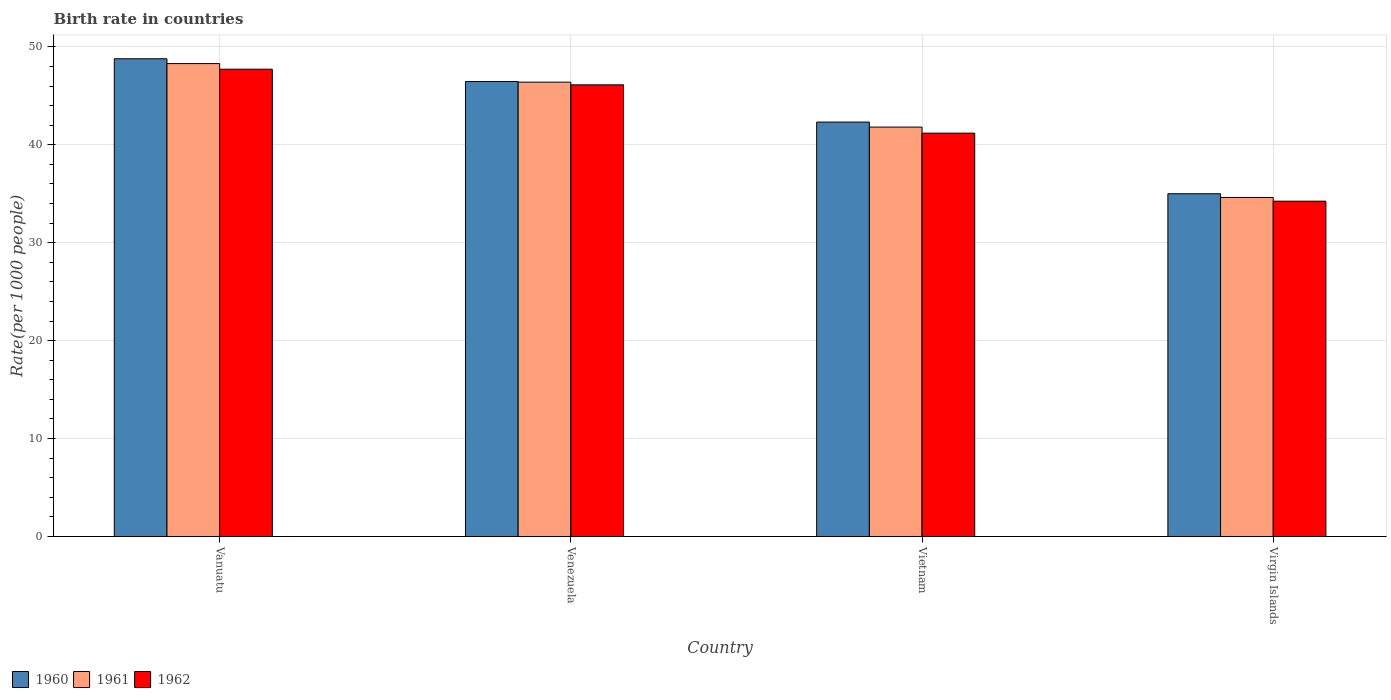How many different coloured bars are there?
Provide a short and direct response. 3. How many groups of bars are there?
Your answer should be compact. 4. How many bars are there on the 3rd tick from the right?
Offer a terse response. 3. What is the label of the 2nd group of bars from the left?
Provide a succinct answer. Venezuela. In how many cases, is the number of bars for a given country not equal to the number of legend labels?
Ensure brevity in your answer.  0. What is the birth rate in 1960 in Venezuela?
Ensure brevity in your answer.  46.46. Across all countries, what is the maximum birth rate in 1961?
Offer a terse response. 48.29. Across all countries, what is the minimum birth rate in 1961?
Provide a succinct answer. 34.62. In which country was the birth rate in 1960 maximum?
Make the answer very short. Vanuatu. In which country was the birth rate in 1962 minimum?
Provide a succinct answer. Virgin Islands. What is the total birth rate in 1960 in the graph?
Make the answer very short. 172.56. What is the difference between the birth rate in 1960 in Venezuela and that in Vietnam?
Your answer should be compact. 4.14. What is the difference between the birth rate in 1960 in Virgin Islands and the birth rate in 1961 in Vanuatu?
Provide a short and direct response. -13.29. What is the average birth rate in 1962 per country?
Keep it short and to the point. 42.32. What is the difference between the birth rate of/in 1961 and birth rate of/in 1960 in Vanuatu?
Provide a short and direct response. -0.49. In how many countries, is the birth rate in 1960 greater than 44?
Make the answer very short. 2. What is the ratio of the birth rate in 1961 in Vietnam to that in Virgin Islands?
Ensure brevity in your answer.  1.21. What is the difference between the highest and the second highest birth rate in 1962?
Ensure brevity in your answer.  -4.93. What is the difference between the highest and the lowest birth rate in 1960?
Provide a short and direct response. 13.78. In how many countries, is the birth rate in 1960 greater than the average birth rate in 1960 taken over all countries?
Make the answer very short. 2. Is the sum of the birth rate in 1960 in Venezuela and Virgin Islands greater than the maximum birth rate in 1962 across all countries?
Ensure brevity in your answer.  Yes. What does the 1st bar from the left in Venezuela represents?
Offer a very short reply. 1960. Are all the bars in the graph horizontal?
Give a very brief answer. No. How many countries are there in the graph?
Provide a short and direct response. 4. Does the graph contain any zero values?
Ensure brevity in your answer.  No. Does the graph contain grids?
Your answer should be compact. Yes. Where does the legend appear in the graph?
Ensure brevity in your answer.  Bottom left. How many legend labels are there?
Your answer should be very brief. 3. How are the legend labels stacked?
Keep it short and to the point. Horizontal. What is the title of the graph?
Give a very brief answer. Birth rate in countries. What is the label or title of the X-axis?
Ensure brevity in your answer.  Country. What is the label or title of the Y-axis?
Offer a very short reply. Rate(per 1000 people). What is the Rate(per 1000 people) of 1960 in Vanuatu?
Provide a short and direct response. 48.78. What is the Rate(per 1000 people) of 1961 in Vanuatu?
Give a very brief answer. 48.29. What is the Rate(per 1000 people) of 1962 in Vanuatu?
Make the answer very short. 47.72. What is the Rate(per 1000 people) in 1960 in Venezuela?
Provide a short and direct response. 46.46. What is the Rate(per 1000 people) in 1961 in Venezuela?
Offer a very short reply. 46.39. What is the Rate(per 1000 people) in 1962 in Venezuela?
Your response must be concise. 46.12. What is the Rate(per 1000 people) of 1960 in Vietnam?
Offer a very short reply. 42.32. What is the Rate(per 1000 people) of 1961 in Vietnam?
Provide a succinct answer. 41.81. What is the Rate(per 1000 people) of 1962 in Vietnam?
Offer a terse response. 41.19. What is the Rate(per 1000 people) in 1961 in Virgin Islands?
Offer a terse response. 34.62. What is the Rate(per 1000 people) of 1962 in Virgin Islands?
Offer a very short reply. 34.24. Across all countries, what is the maximum Rate(per 1000 people) in 1960?
Make the answer very short. 48.78. Across all countries, what is the maximum Rate(per 1000 people) in 1961?
Keep it short and to the point. 48.29. Across all countries, what is the maximum Rate(per 1000 people) in 1962?
Keep it short and to the point. 47.72. Across all countries, what is the minimum Rate(per 1000 people) in 1961?
Offer a very short reply. 34.62. Across all countries, what is the minimum Rate(per 1000 people) in 1962?
Keep it short and to the point. 34.24. What is the total Rate(per 1000 people) of 1960 in the graph?
Ensure brevity in your answer.  172.56. What is the total Rate(per 1000 people) in 1961 in the graph?
Provide a succinct answer. 171.11. What is the total Rate(per 1000 people) of 1962 in the graph?
Make the answer very short. 169.26. What is the difference between the Rate(per 1000 people) of 1960 in Vanuatu and that in Venezuela?
Offer a very short reply. 2.32. What is the difference between the Rate(per 1000 people) of 1961 in Vanuatu and that in Venezuela?
Provide a short and direct response. 1.9. What is the difference between the Rate(per 1000 people) in 1962 in Vanuatu and that in Venezuela?
Ensure brevity in your answer.  1.59. What is the difference between the Rate(per 1000 people) of 1960 in Vanuatu and that in Vietnam?
Offer a very short reply. 6.46. What is the difference between the Rate(per 1000 people) in 1961 in Vanuatu and that in Vietnam?
Your response must be concise. 6.48. What is the difference between the Rate(per 1000 people) of 1962 in Vanuatu and that in Vietnam?
Ensure brevity in your answer.  6.53. What is the difference between the Rate(per 1000 people) in 1960 in Vanuatu and that in Virgin Islands?
Keep it short and to the point. 13.78. What is the difference between the Rate(per 1000 people) in 1961 in Vanuatu and that in Virgin Islands?
Provide a short and direct response. 13.67. What is the difference between the Rate(per 1000 people) in 1962 in Vanuatu and that in Virgin Islands?
Offer a terse response. 13.48. What is the difference between the Rate(per 1000 people) in 1960 in Venezuela and that in Vietnam?
Provide a succinct answer. 4.14. What is the difference between the Rate(per 1000 people) of 1961 in Venezuela and that in Vietnam?
Give a very brief answer. 4.59. What is the difference between the Rate(per 1000 people) of 1962 in Venezuela and that in Vietnam?
Give a very brief answer. 4.93. What is the difference between the Rate(per 1000 people) of 1960 in Venezuela and that in Virgin Islands?
Keep it short and to the point. 11.46. What is the difference between the Rate(per 1000 people) in 1961 in Venezuela and that in Virgin Islands?
Provide a short and direct response. 11.77. What is the difference between the Rate(per 1000 people) in 1962 in Venezuela and that in Virgin Islands?
Your response must be concise. 11.88. What is the difference between the Rate(per 1000 people) of 1960 in Vietnam and that in Virgin Islands?
Provide a succinct answer. 7.32. What is the difference between the Rate(per 1000 people) in 1961 in Vietnam and that in Virgin Islands?
Your answer should be very brief. 7.19. What is the difference between the Rate(per 1000 people) in 1962 in Vietnam and that in Virgin Islands?
Your answer should be very brief. 6.95. What is the difference between the Rate(per 1000 people) of 1960 in Vanuatu and the Rate(per 1000 people) of 1961 in Venezuela?
Your answer should be compact. 2.39. What is the difference between the Rate(per 1000 people) of 1960 in Vanuatu and the Rate(per 1000 people) of 1962 in Venezuela?
Provide a succinct answer. 2.66. What is the difference between the Rate(per 1000 people) in 1961 in Vanuatu and the Rate(per 1000 people) in 1962 in Venezuela?
Provide a succinct answer. 2.17. What is the difference between the Rate(per 1000 people) in 1960 in Vanuatu and the Rate(per 1000 people) in 1961 in Vietnam?
Make the answer very short. 6.98. What is the difference between the Rate(per 1000 people) of 1960 in Vanuatu and the Rate(per 1000 people) of 1962 in Vietnam?
Offer a terse response. 7.6. What is the difference between the Rate(per 1000 people) in 1961 in Vanuatu and the Rate(per 1000 people) in 1962 in Vietnam?
Ensure brevity in your answer.  7.1. What is the difference between the Rate(per 1000 people) of 1960 in Vanuatu and the Rate(per 1000 people) of 1961 in Virgin Islands?
Offer a terse response. 14.16. What is the difference between the Rate(per 1000 people) of 1960 in Vanuatu and the Rate(per 1000 people) of 1962 in Virgin Islands?
Your response must be concise. 14.54. What is the difference between the Rate(per 1000 people) of 1961 in Vanuatu and the Rate(per 1000 people) of 1962 in Virgin Islands?
Your answer should be compact. 14.05. What is the difference between the Rate(per 1000 people) in 1960 in Venezuela and the Rate(per 1000 people) in 1961 in Vietnam?
Make the answer very short. 4.66. What is the difference between the Rate(per 1000 people) of 1960 in Venezuela and the Rate(per 1000 people) of 1962 in Vietnam?
Provide a short and direct response. 5.27. What is the difference between the Rate(per 1000 people) of 1961 in Venezuela and the Rate(per 1000 people) of 1962 in Vietnam?
Ensure brevity in your answer.  5.21. What is the difference between the Rate(per 1000 people) of 1960 in Venezuela and the Rate(per 1000 people) of 1961 in Virgin Islands?
Your response must be concise. 11.84. What is the difference between the Rate(per 1000 people) in 1960 in Venezuela and the Rate(per 1000 people) in 1962 in Virgin Islands?
Provide a succinct answer. 12.22. What is the difference between the Rate(per 1000 people) of 1961 in Venezuela and the Rate(per 1000 people) of 1962 in Virgin Islands?
Give a very brief answer. 12.15. What is the difference between the Rate(per 1000 people) of 1960 in Vietnam and the Rate(per 1000 people) of 1961 in Virgin Islands?
Ensure brevity in your answer.  7.7. What is the difference between the Rate(per 1000 people) of 1960 in Vietnam and the Rate(per 1000 people) of 1962 in Virgin Islands?
Provide a succinct answer. 8.08. What is the difference between the Rate(per 1000 people) of 1961 in Vietnam and the Rate(per 1000 people) of 1962 in Virgin Islands?
Your answer should be very brief. 7.57. What is the average Rate(per 1000 people) in 1960 per country?
Provide a succinct answer. 43.14. What is the average Rate(per 1000 people) of 1961 per country?
Offer a terse response. 42.78. What is the average Rate(per 1000 people) in 1962 per country?
Offer a very short reply. 42.32. What is the difference between the Rate(per 1000 people) of 1960 and Rate(per 1000 people) of 1961 in Vanuatu?
Provide a short and direct response. 0.49. What is the difference between the Rate(per 1000 people) of 1960 and Rate(per 1000 people) of 1962 in Vanuatu?
Offer a very short reply. 1.07. What is the difference between the Rate(per 1000 people) of 1961 and Rate(per 1000 people) of 1962 in Vanuatu?
Your answer should be very brief. 0.57. What is the difference between the Rate(per 1000 people) in 1960 and Rate(per 1000 people) in 1961 in Venezuela?
Offer a terse response. 0.07. What is the difference between the Rate(per 1000 people) in 1960 and Rate(per 1000 people) in 1962 in Venezuela?
Give a very brief answer. 0.34. What is the difference between the Rate(per 1000 people) of 1961 and Rate(per 1000 people) of 1962 in Venezuela?
Give a very brief answer. 0.27. What is the difference between the Rate(per 1000 people) of 1960 and Rate(per 1000 people) of 1961 in Vietnam?
Offer a terse response. 0.51. What is the difference between the Rate(per 1000 people) in 1960 and Rate(per 1000 people) in 1962 in Vietnam?
Provide a succinct answer. 1.13. What is the difference between the Rate(per 1000 people) of 1961 and Rate(per 1000 people) of 1962 in Vietnam?
Make the answer very short. 0.62. What is the difference between the Rate(per 1000 people) of 1960 and Rate(per 1000 people) of 1961 in Virgin Islands?
Your answer should be very brief. 0.38. What is the difference between the Rate(per 1000 people) in 1960 and Rate(per 1000 people) in 1962 in Virgin Islands?
Keep it short and to the point. 0.76. What is the difference between the Rate(per 1000 people) of 1961 and Rate(per 1000 people) of 1962 in Virgin Islands?
Provide a succinct answer. 0.38. What is the ratio of the Rate(per 1000 people) in 1961 in Vanuatu to that in Venezuela?
Ensure brevity in your answer.  1.04. What is the ratio of the Rate(per 1000 people) of 1962 in Vanuatu to that in Venezuela?
Provide a succinct answer. 1.03. What is the ratio of the Rate(per 1000 people) in 1960 in Vanuatu to that in Vietnam?
Your answer should be very brief. 1.15. What is the ratio of the Rate(per 1000 people) of 1961 in Vanuatu to that in Vietnam?
Make the answer very short. 1.16. What is the ratio of the Rate(per 1000 people) of 1962 in Vanuatu to that in Vietnam?
Your answer should be compact. 1.16. What is the ratio of the Rate(per 1000 people) in 1960 in Vanuatu to that in Virgin Islands?
Provide a succinct answer. 1.39. What is the ratio of the Rate(per 1000 people) in 1961 in Vanuatu to that in Virgin Islands?
Provide a succinct answer. 1.39. What is the ratio of the Rate(per 1000 people) in 1962 in Vanuatu to that in Virgin Islands?
Your answer should be compact. 1.39. What is the ratio of the Rate(per 1000 people) in 1960 in Venezuela to that in Vietnam?
Offer a terse response. 1.1. What is the ratio of the Rate(per 1000 people) of 1961 in Venezuela to that in Vietnam?
Your response must be concise. 1.11. What is the ratio of the Rate(per 1000 people) in 1962 in Venezuela to that in Vietnam?
Your response must be concise. 1.12. What is the ratio of the Rate(per 1000 people) in 1960 in Venezuela to that in Virgin Islands?
Your response must be concise. 1.33. What is the ratio of the Rate(per 1000 people) in 1961 in Venezuela to that in Virgin Islands?
Ensure brevity in your answer.  1.34. What is the ratio of the Rate(per 1000 people) of 1962 in Venezuela to that in Virgin Islands?
Keep it short and to the point. 1.35. What is the ratio of the Rate(per 1000 people) in 1960 in Vietnam to that in Virgin Islands?
Provide a short and direct response. 1.21. What is the ratio of the Rate(per 1000 people) of 1961 in Vietnam to that in Virgin Islands?
Offer a terse response. 1.21. What is the ratio of the Rate(per 1000 people) in 1962 in Vietnam to that in Virgin Islands?
Give a very brief answer. 1.2. What is the difference between the highest and the second highest Rate(per 1000 people) in 1960?
Give a very brief answer. 2.32. What is the difference between the highest and the second highest Rate(per 1000 people) of 1961?
Provide a short and direct response. 1.9. What is the difference between the highest and the second highest Rate(per 1000 people) in 1962?
Your response must be concise. 1.59. What is the difference between the highest and the lowest Rate(per 1000 people) of 1960?
Offer a terse response. 13.78. What is the difference between the highest and the lowest Rate(per 1000 people) in 1961?
Provide a short and direct response. 13.67. What is the difference between the highest and the lowest Rate(per 1000 people) of 1962?
Offer a very short reply. 13.48. 